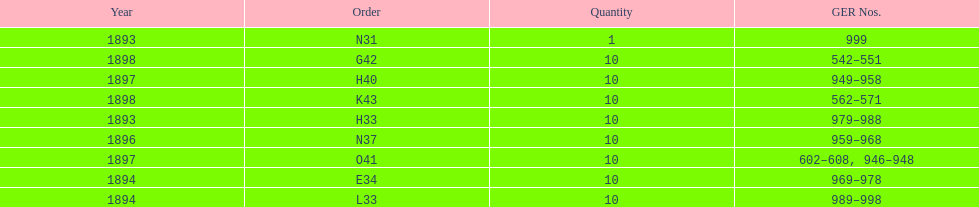Which order was the next order after l33? E34. 